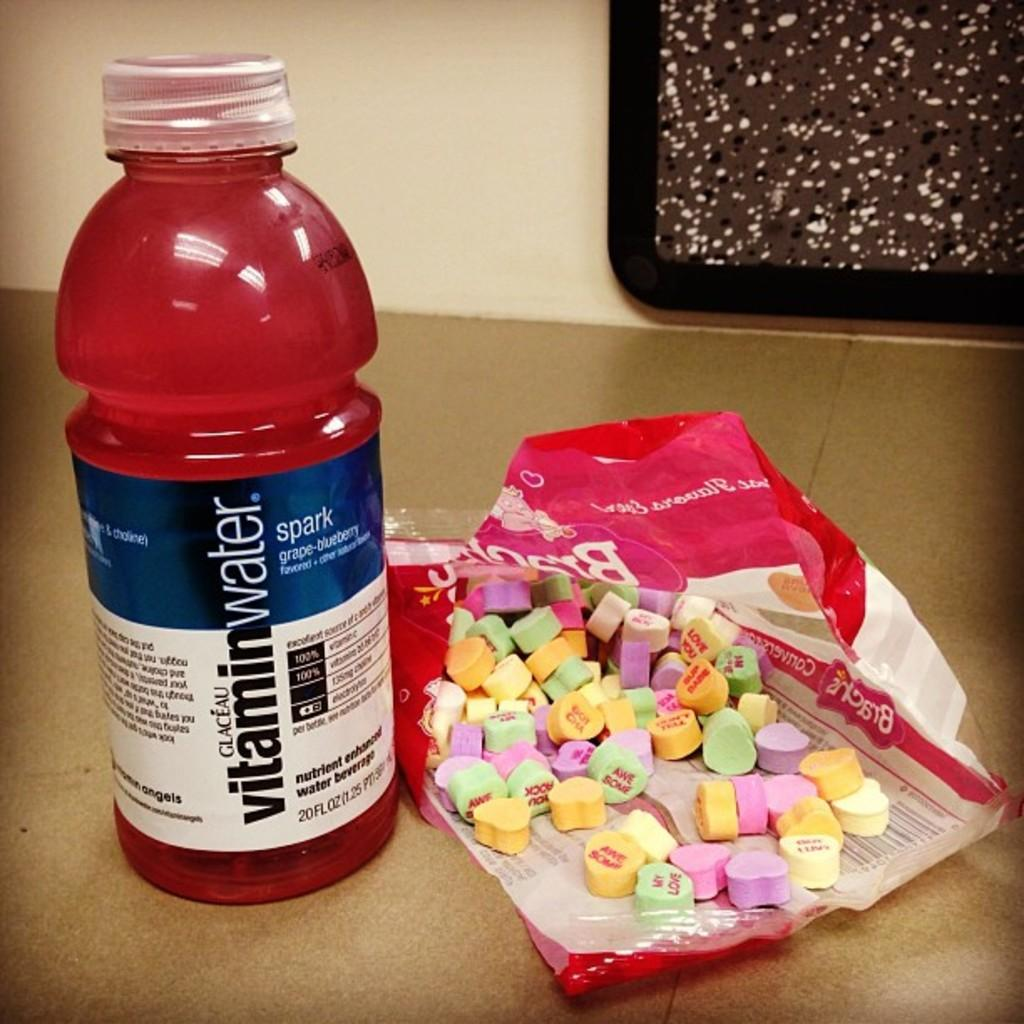<image>
Render a clear and concise summary of the photo. A bottle of red vitamin water sits next to an open bag of unhealthy looking candy. 